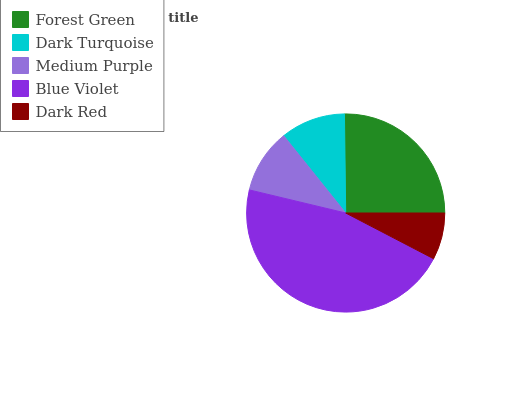Is Dark Red the minimum?
Answer yes or no. Yes. Is Blue Violet the maximum?
Answer yes or no. Yes. Is Dark Turquoise the minimum?
Answer yes or no. No. Is Dark Turquoise the maximum?
Answer yes or no. No. Is Forest Green greater than Dark Turquoise?
Answer yes or no. Yes. Is Dark Turquoise less than Forest Green?
Answer yes or no. Yes. Is Dark Turquoise greater than Forest Green?
Answer yes or no. No. Is Forest Green less than Dark Turquoise?
Answer yes or no. No. Is Dark Turquoise the high median?
Answer yes or no. Yes. Is Dark Turquoise the low median?
Answer yes or no. Yes. Is Dark Red the high median?
Answer yes or no. No. Is Forest Green the low median?
Answer yes or no. No. 